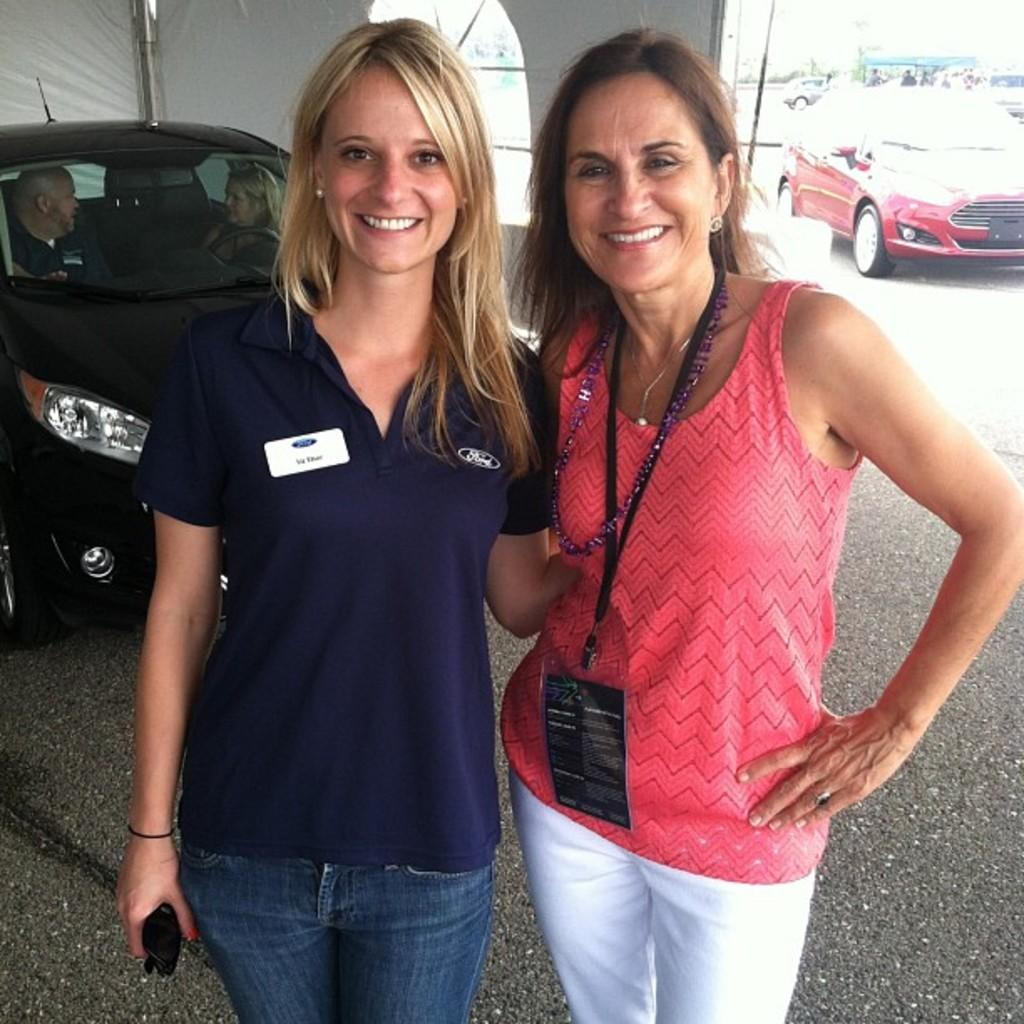How many women are present in the image? There are two women in the image. What are the women doing in the image? The women are posing for a camera. Can you describe something in the background of the image? There is a car in the background of the image. What type of board can be seen being used by the women in the image? There is no board present in the image; the women are posing for a camera. Can you tell me how many stars are visible in the image? There are no stars visible in the image, as it appears to be taken during the day. 